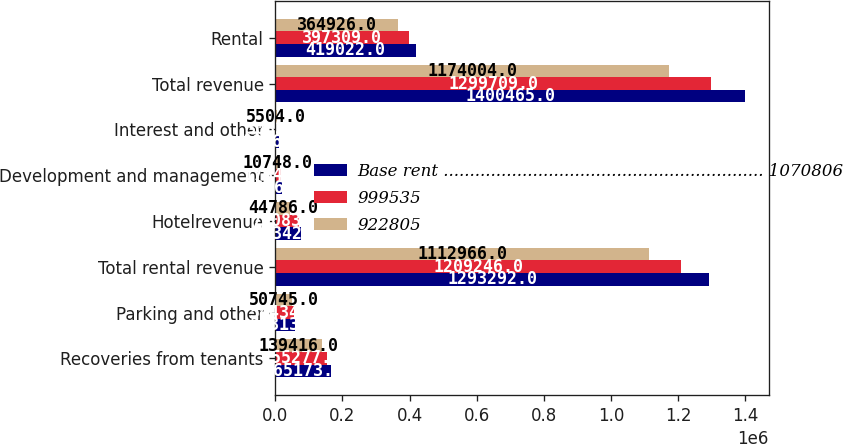Convert chart to OTSL. <chart><loc_0><loc_0><loc_500><loc_500><stacked_bar_chart><ecel><fcel>Recoveries from tenants<fcel>Parking and other<fcel>Total rental revenue<fcel>Hotelrevenue<fcel>Development and management<fcel>Interest and other<fcel>Total revenue<fcel>Rental<nl><fcel>Base rent ............................................................. 1070806<fcel>165173<fcel>57313<fcel>1.29329e+06<fcel>76342<fcel>20464<fcel>10367<fcel>1.40046e+06<fcel>419022<nl><fcel>999535<fcel>155277<fcel>54434<fcel>1.20925e+06<fcel>70083<fcel>17347<fcel>3033<fcel>1.29971e+06<fcel>397309<nl><fcel>922805<fcel>139416<fcel>50745<fcel>1.11297e+06<fcel>44786<fcel>10748<fcel>5504<fcel>1.174e+06<fcel>364926<nl></chart> 